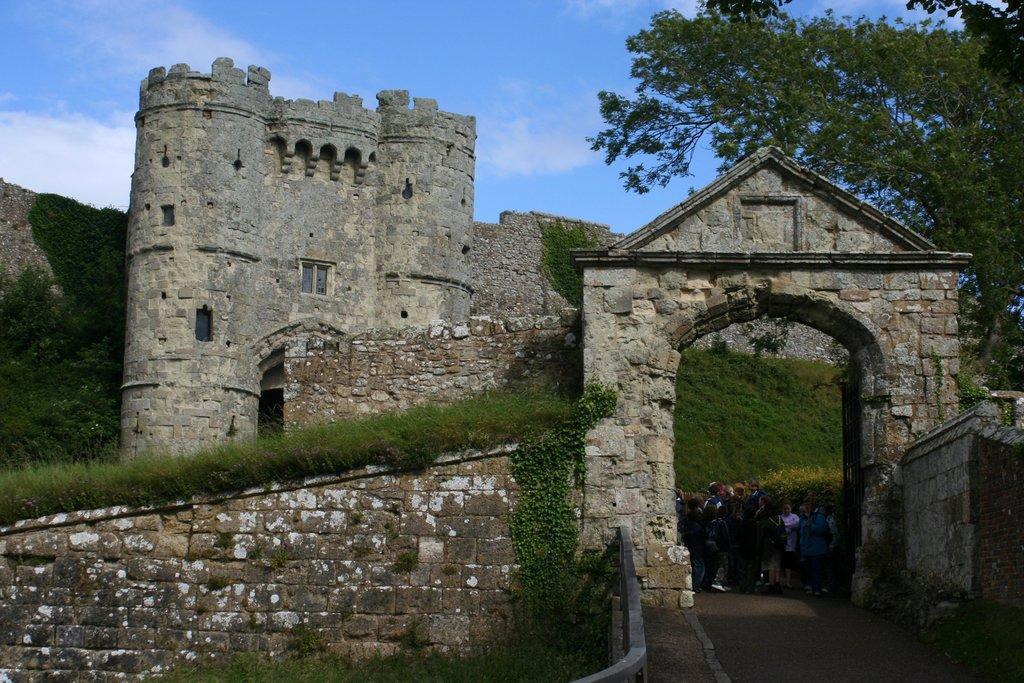Describe this image in one or two sentences. On the right side there is an entrance with brick wall. Near to that some people are standing. Also there is a fort with bricks and windows. There are trees. In the background there is sky. 